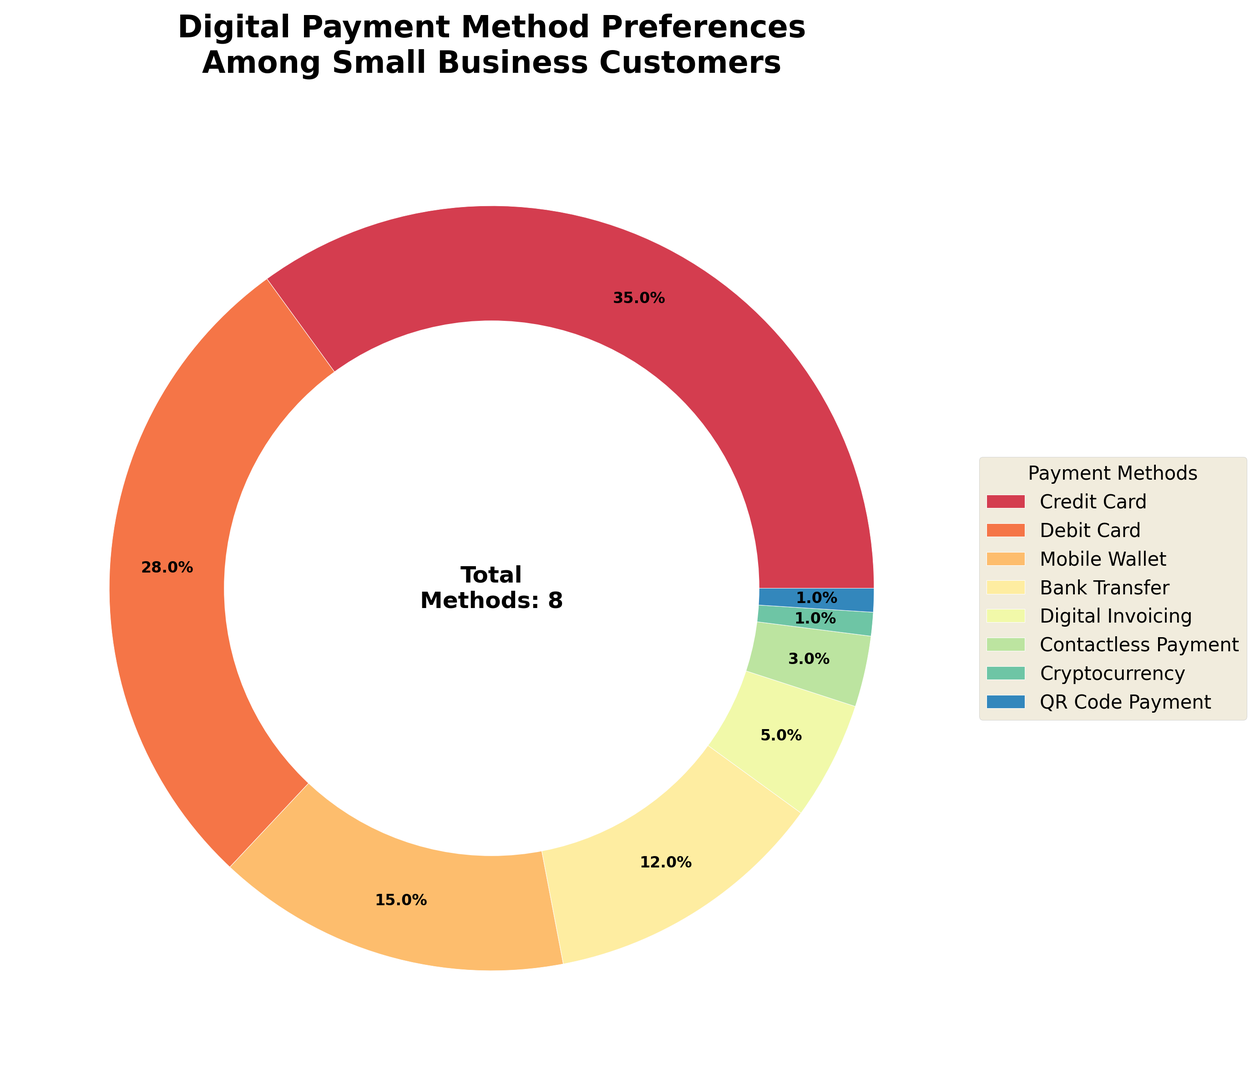Which digital payment method is preferred by the highest percentage of small business customers? The ring chart shows that the Digital Payment Method with the largest section is the Credit Card, which occupies 35%.
Answer: Credit Card How much more popular is the Credit Card method compared to Cryptocurrency? According to the chart, Credit Card has a 35% preference and Cryptocurrency has a 1% preference. So, the difference is 35 - 1 = 34%.
Answer: 34% What is the combined percentage of users who prefer Mobile Wallet, Bank Transfer, and Digital Invoicing? The percentages for Mobile Wallet, Bank Transfer, and Digital Invoicing are 15%, 12%, and 5% respectively. Summing these: 15 + 12 + 5 = 32%.
Answer: 32% Which two methods combined have nearly the same preference as Debit Card? Debit Card has a preference of 28%. The combined percentages of Mobile Wallet (15%) and Bank Transfer (12%) sum to 15 + 12 = 27%, which is closest to 28%.
Answer: Mobile Wallet and Bank Transfer Which payment methods have a preference less than or equal to 3%? The ring chart shows that Contactless Payment (3%), Cryptocurrency (1%), and QR Code Payment (1%) have preferences less than or equal to 3%.
Answer: Contactless Payment, Cryptocurrency, and QR Code Payment Is Mobile Wallet more preferred than Contactless Payment? The preference for Mobile Wallet is 15%, which is greater than the 3% preference for Contactless Payment, as visually represented in the chart.
Answer: Yes What is the difference in preference between Debit Card and Mobile Wallet? The preference for Debit Card is 28%, and for Mobile Wallet, it is 15%. The difference is 28 - 15 = 13%.
Answer: 13% Which payment method is the least preferred by small business customers? The chart shows that Cryptocurrency and QR Code Payment each have a 1% preference, making them the least preferred methods.
Answer: Cryptocurrency and QR Code Payment How many payment methods have a preference greater than 10%? By looking at the chart, Credit Card (35%), Debit Card (28%), Mobile Wallet (15%), and Bank Transfer (12%) have a preference greater than 10%. There are 4 such methods.
Answer: 4 What additional information is provided at the center of the ring chart? The text at the center of the chart states "Total Methods: 8," indicating the total number of different payment methods shown in the chart.
Answer: Total Methods: 8 